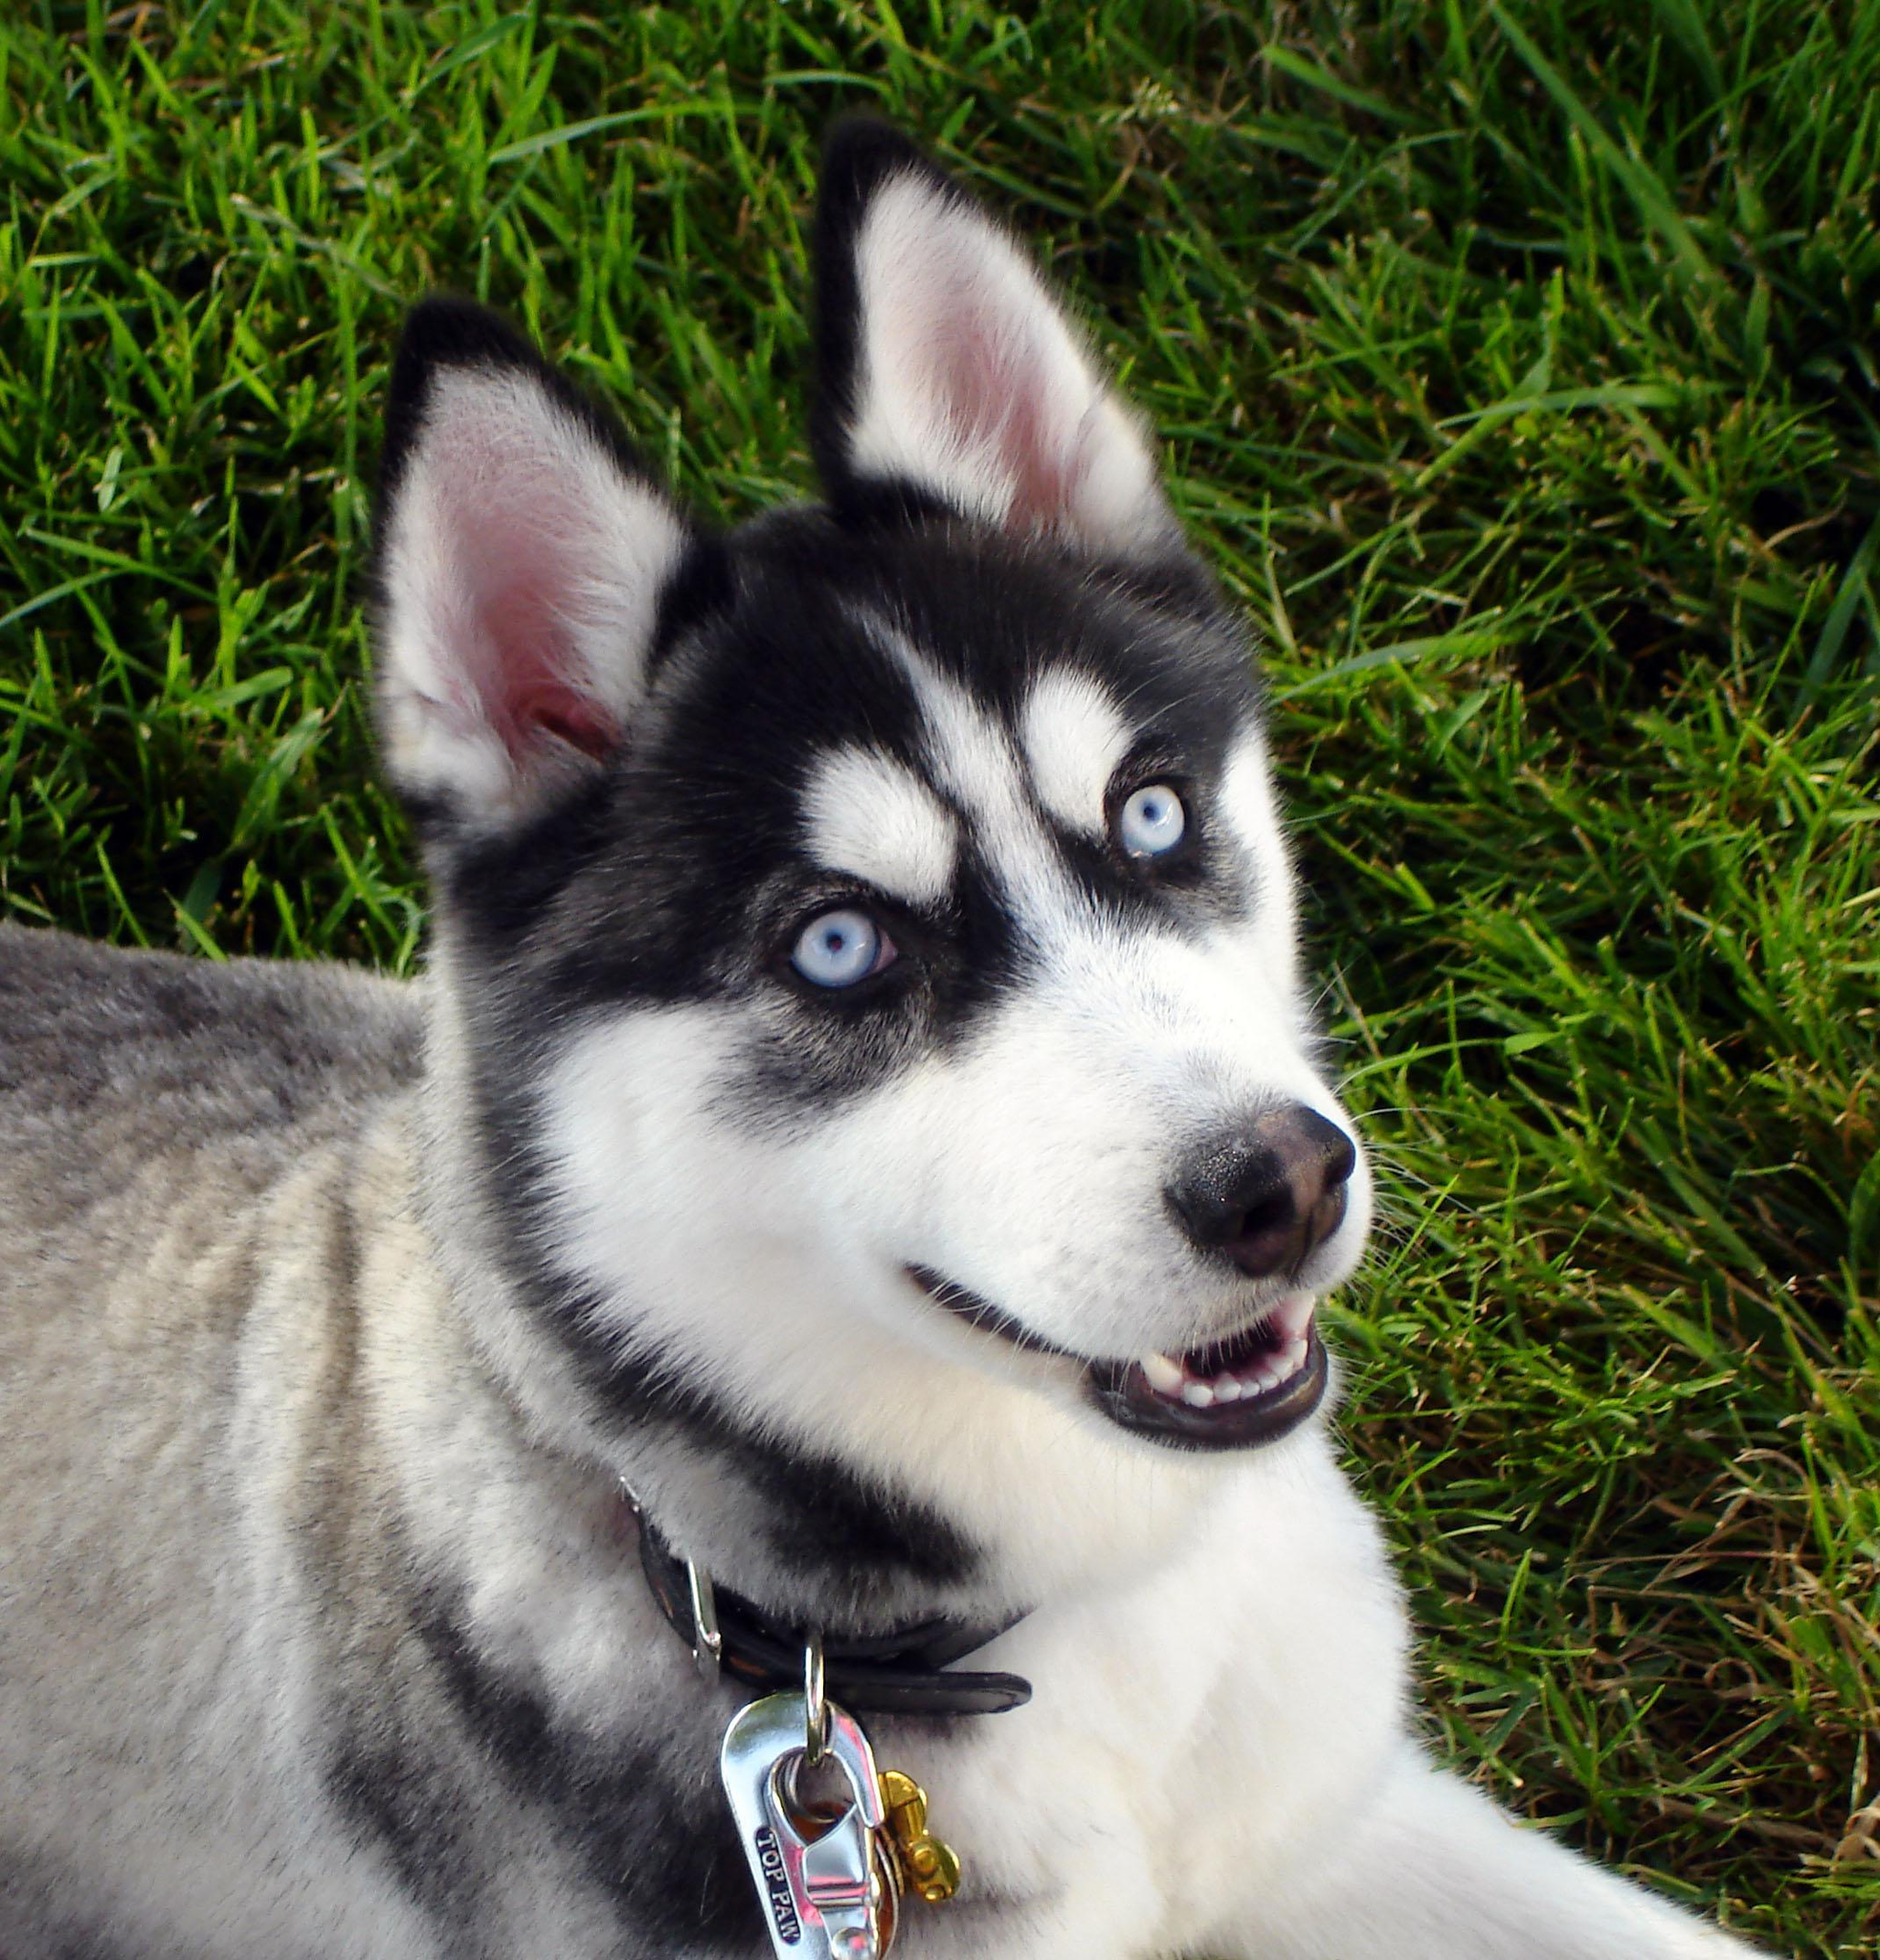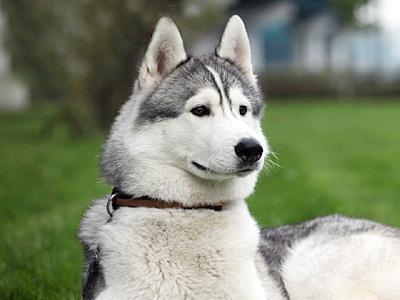The first image is the image on the left, the second image is the image on the right. Given the left and right images, does the statement "The left and right image contains the same number of dogs with one puppy and one adult." hold true? Answer yes or no. No. 